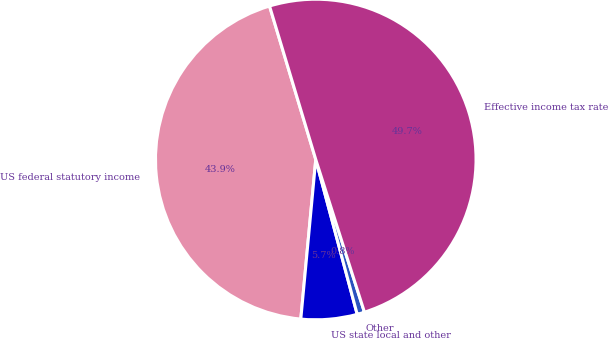Convert chart. <chart><loc_0><loc_0><loc_500><loc_500><pie_chart><fcel>US federal statutory income<fcel>US state local and other<fcel>Other<fcel>Effective income tax rate<nl><fcel>43.85%<fcel>5.65%<fcel>0.75%<fcel>49.74%<nl></chart> 